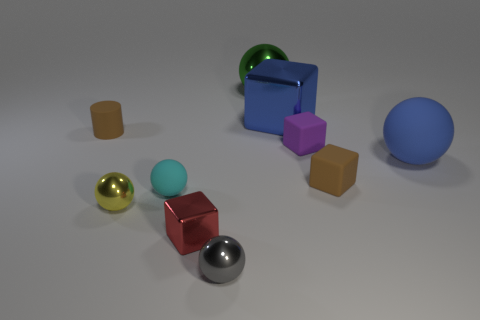Do the green object and the blue sphere have the same size?
Offer a terse response. Yes. The cyan matte thing that is the same size as the gray metal ball is what shape?
Your answer should be very brief. Sphere. There is a cube on the left side of the green metallic ball; is it the same size as the purple object?
Ensure brevity in your answer.  Yes. There is a green sphere that is the same size as the blue metal thing; what is its material?
Give a very brief answer. Metal. There is a large blue sphere that is behind the small ball on the left side of the cyan matte thing; is there a red thing that is behind it?
Give a very brief answer. No. Is there any other thing that has the same shape as the tiny gray metal object?
Ensure brevity in your answer.  Yes. Do the ball behind the purple thing and the shiny block in front of the brown cylinder have the same color?
Provide a succinct answer. No. Are any blue blocks visible?
Ensure brevity in your answer.  Yes. There is a block that is the same color as the big matte thing; what is its material?
Provide a short and direct response. Metal. There is a brown thing in front of the big blue object in front of the tiny brown object behind the purple matte block; what is its size?
Offer a very short reply. Small. 